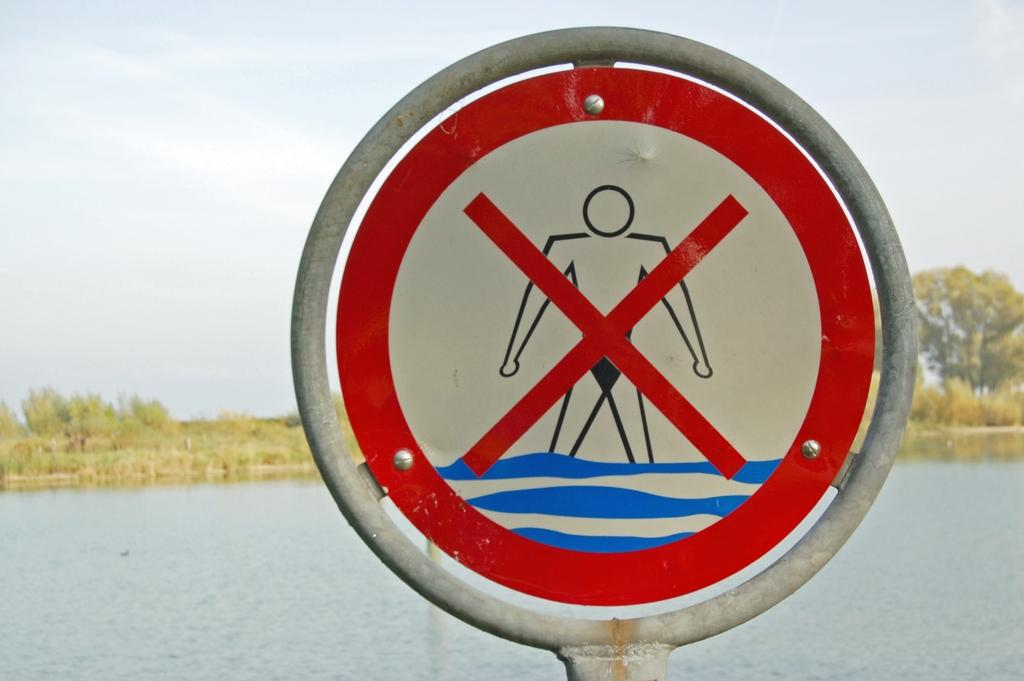What is located in the middle of the image? There is a sign board in the middle of the image. What can be seen at the bottom of the image? There is water at the bottom of the image. What type of vegetation is visible in the background of the image? There are plants in the background of the image. What is visible at the top of the image? The sky is visible at the top of the image. Can you see a net holding the plants in the image? There is no net present in the image. 